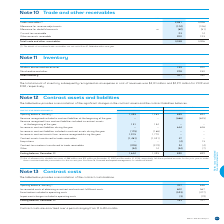According to Bce's financial document, What is the range of periods for contract cost amortization? According to the financial document, 12 to 84 months. The relevant text states: "ct costs are amortized over a period ranging from 12 to 84 months...." Also, What is the opening balance in 2019? According to the financial document, 707. The relevant text states: "Opening balance, January 1 707 636..." Also, What is the ending balance in 2019? According to the financial document, 783. The relevant text states: "Ending balance, December 31 783 707..." Also, can you calculate: What is the difference in the opening and ending balances in 2019? Based on the calculation: 783-707, the result is 76. This is based on the information: "Ending balance, December 31 783 707 Ending balance, December 31 783 707..." The key data points involved are: 707, 783. Also, can you calculate: What is the total incremental costs of obtaining a contract and contract fulfillment costs in 2018 and 2019? Based on the calculation: 602+567, the result is 1169. This is based on the information: "taining a contract and contract fulfillment costs 602 567 ing a contract and contract fulfillment costs 602 567..." The key data points involved are: 567, 602. Also, can you calculate: What is the change in the incremental costs of obtaining a contract and contract fulfillment costs in 2018 to 2019? Based on the calculation: 602-567, the result is 35. This is based on the information: "taining a contract and contract fulfillment costs 602 567 ing a contract and contract fulfillment costs 602 567..." The key data points involved are: 567, 602. 